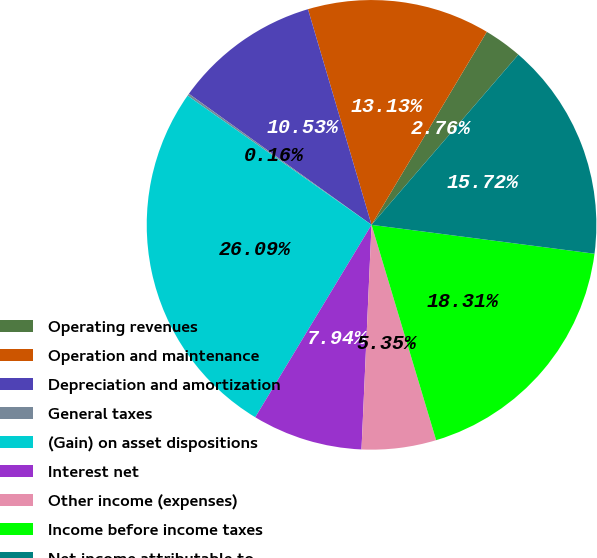Convert chart to OTSL. <chart><loc_0><loc_0><loc_500><loc_500><pie_chart><fcel>Operating revenues<fcel>Operation and maintenance<fcel>Depreciation and amortization<fcel>General taxes<fcel>(Gain) on asset dispositions<fcel>Interest net<fcel>Other income (expenses)<fcel>Income before income taxes<fcel>Net income attributable to<nl><fcel>2.76%<fcel>13.13%<fcel>10.53%<fcel>0.16%<fcel>26.09%<fcel>7.94%<fcel>5.35%<fcel>18.31%<fcel>15.72%<nl></chart> 